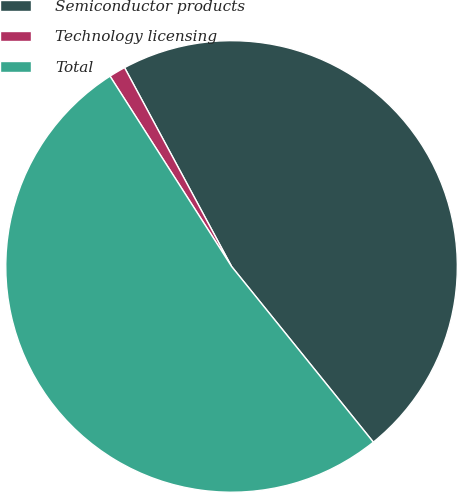Convert chart. <chart><loc_0><loc_0><loc_500><loc_500><pie_chart><fcel>Semiconductor products<fcel>Technology licensing<fcel>Total<nl><fcel>47.05%<fcel>1.19%<fcel>51.76%<nl></chart> 